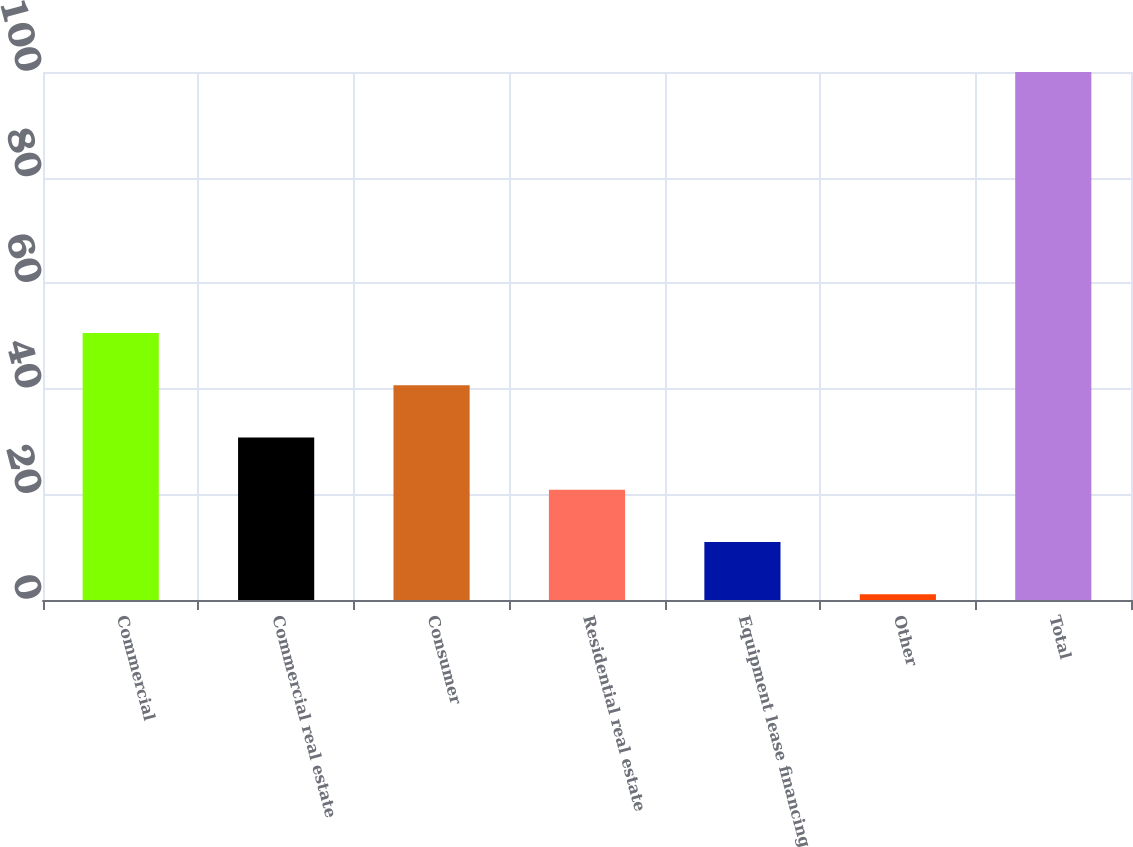Convert chart to OTSL. <chart><loc_0><loc_0><loc_500><loc_500><bar_chart><fcel>Commercial<fcel>Commercial real estate<fcel>Consumer<fcel>Residential real estate<fcel>Equipment lease financing<fcel>Other<fcel>Total<nl><fcel>50.55<fcel>30.77<fcel>40.66<fcel>20.88<fcel>10.99<fcel>1.1<fcel>100<nl></chart> 